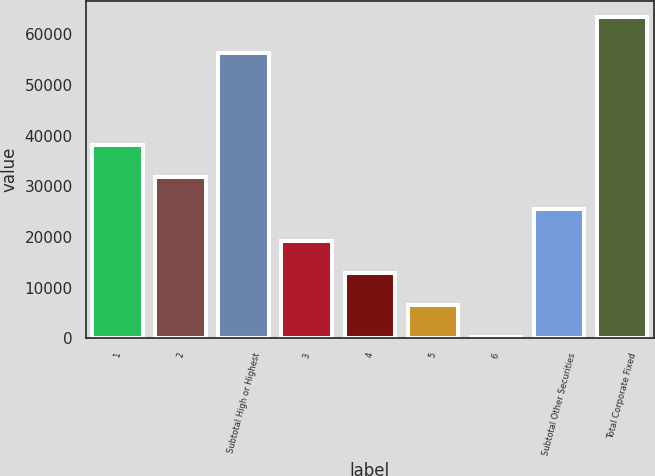Convert chart to OTSL. <chart><loc_0><loc_0><loc_500><loc_500><bar_chart><fcel>1<fcel>2<fcel>Subtotal High or Highest<fcel>3<fcel>4<fcel>5<fcel>6<fcel>Subtotal Other Securities<fcel>Total Corporate Fixed<nl><fcel>38228<fcel>31909.5<fcel>56223<fcel>19272.5<fcel>12954<fcel>6635.5<fcel>317<fcel>25591<fcel>63502<nl></chart> 